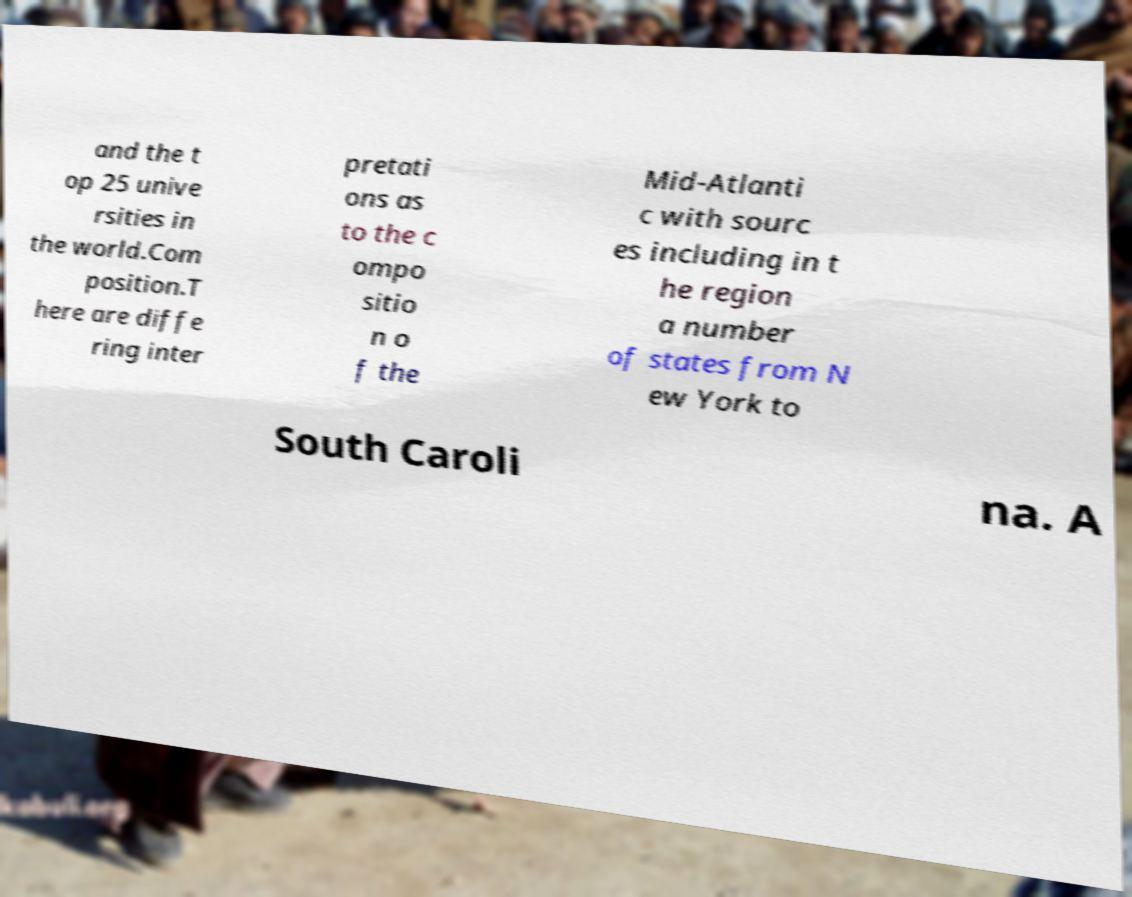Please identify and transcribe the text found in this image. and the t op 25 unive rsities in the world.Com position.T here are diffe ring inter pretati ons as to the c ompo sitio n o f the Mid-Atlanti c with sourc es including in t he region a number of states from N ew York to South Caroli na. A 